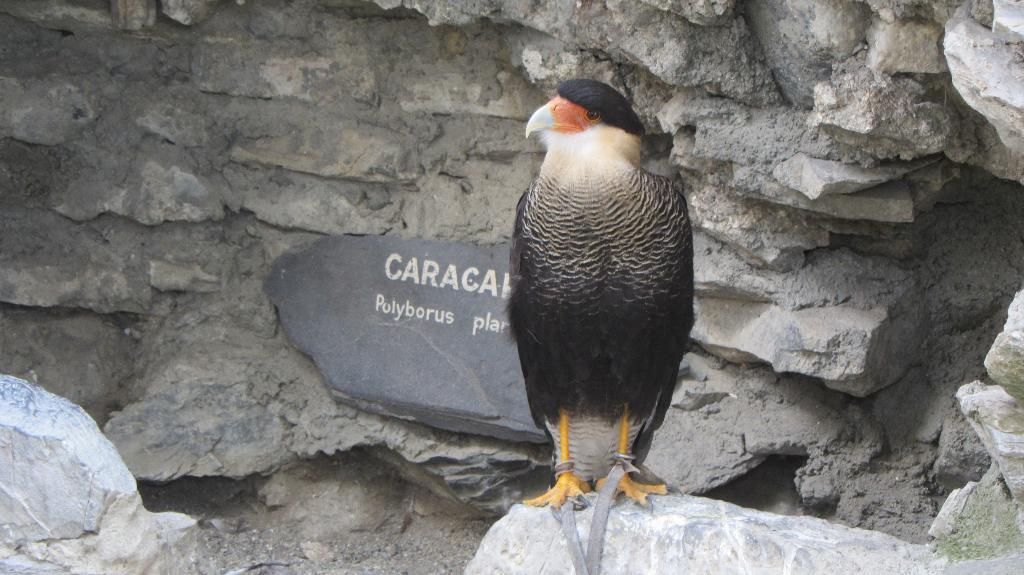What type of bird is in the image? There is a Falconiformes in the image. What is the Falconiformes standing on? The Falconiformes is standing on a rock. Is there any text or writing visible in the image? Yes, there is writing visible behind the Falconiformes. What type of sand can be seen on the ground in the image? There is no sand visible in the image; the Falconiformes is standing on a rock. 